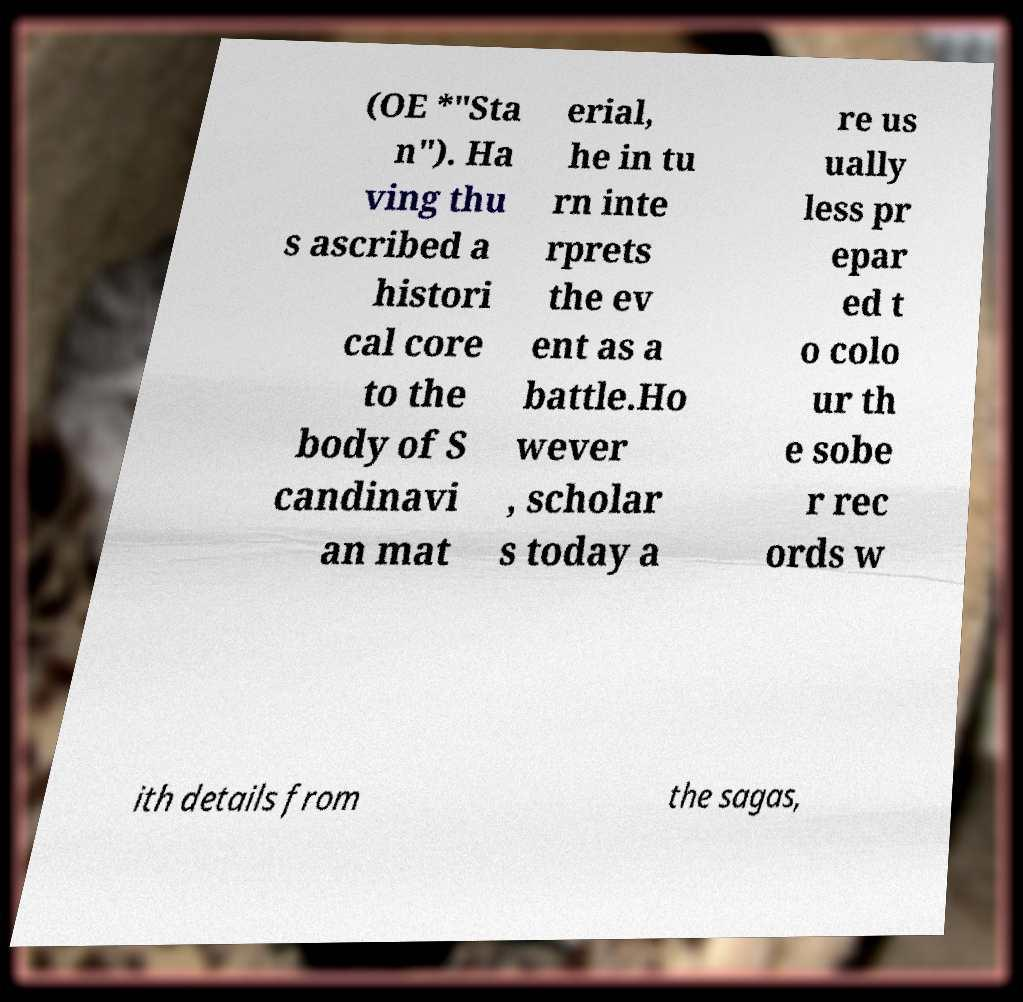Can you read and provide the text displayed in the image?This photo seems to have some interesting text. Can you extract and type it out for me? (OE *"Sta n"). Ha ving thu s ascribed a histori cal core to the body of S candinavi an mat erial, he in tu rn inte rprets the ev ent as a battle.Ho wever , scholar s today a re us ually less pr epar ed t o colo ur th e sobe r rec ords w ith details from the sagas, 